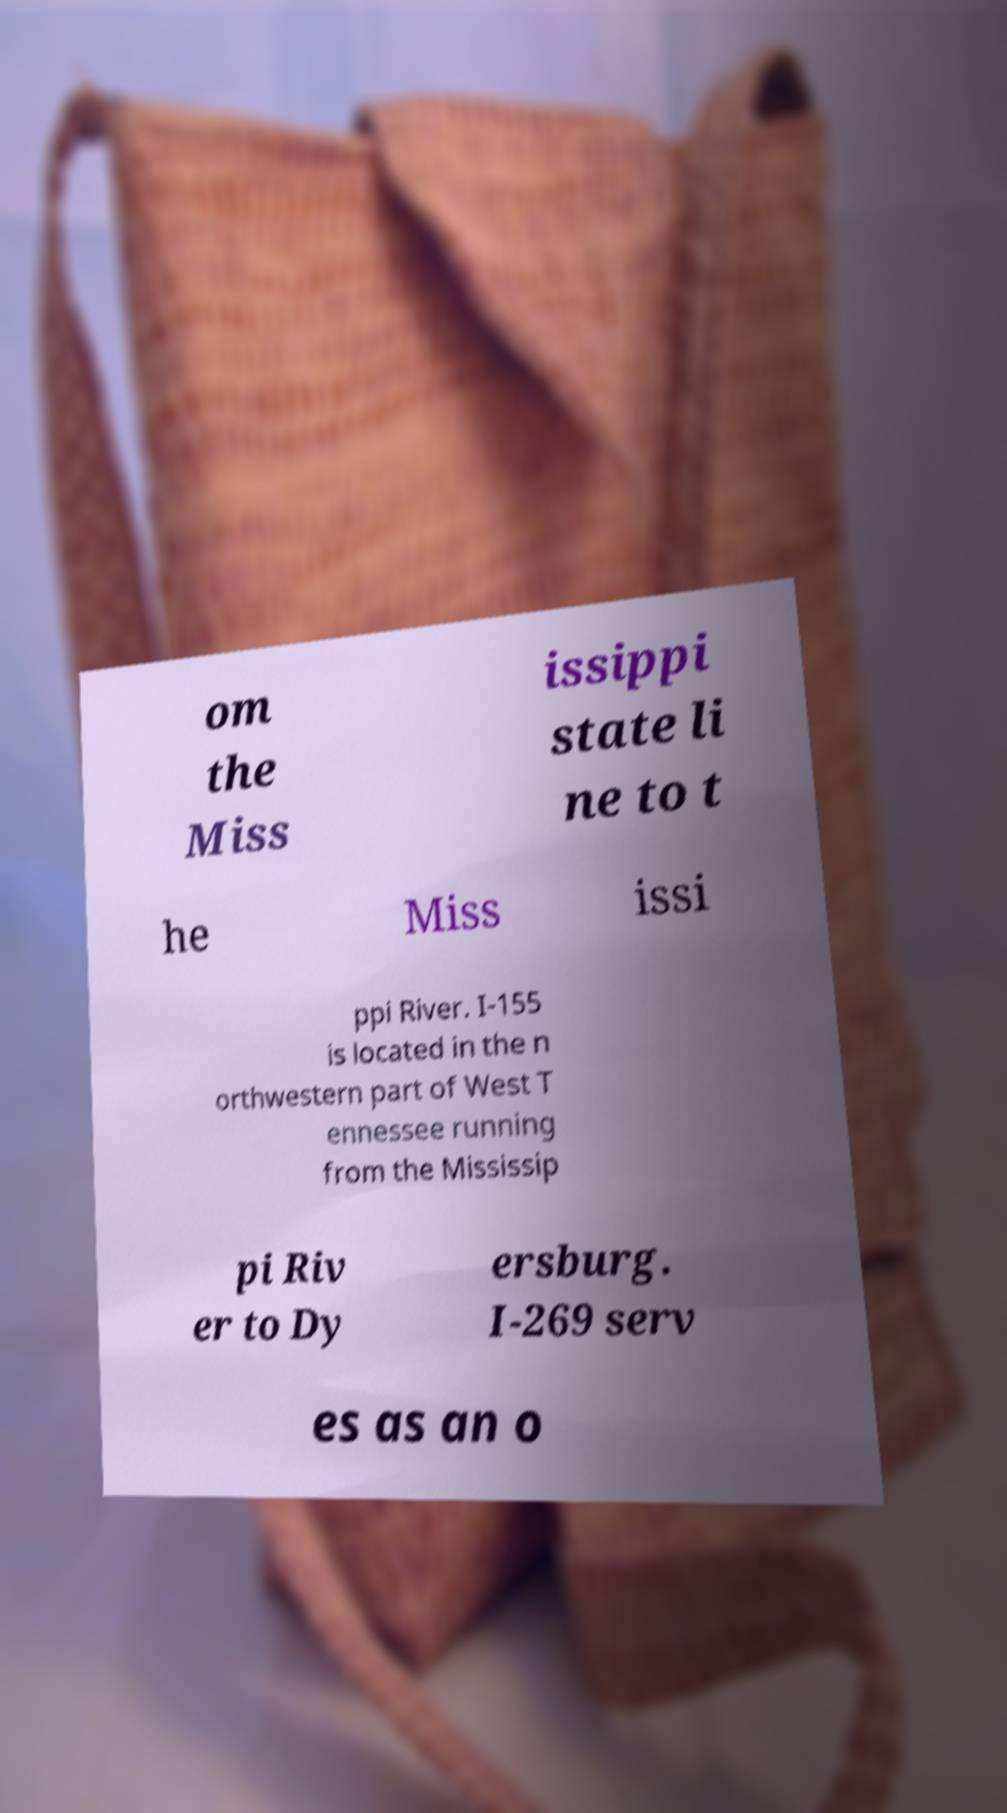Can you accurately transcribe the text from the provided image for me? om the Miss issippi state li ne to t he Miss issi ppi River. I-155 is located in the n orthwestern part of West T ennessee running from the Mississip pi Riv er to Dy ersburg. I-269 serv es as an o 